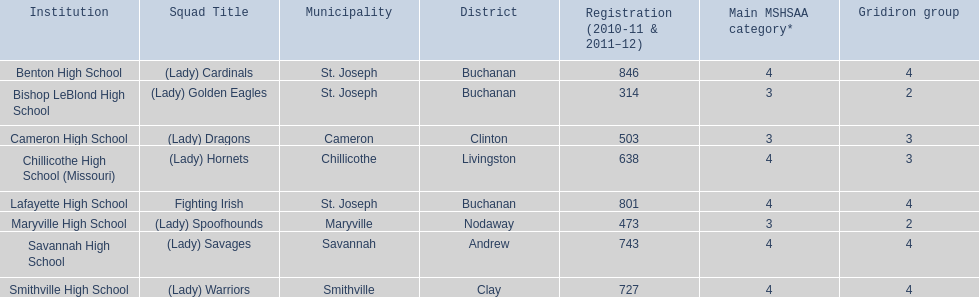What school in midland empire conference has 846 students enrolled? Benton High School. What school has 314 students enrolled? Bishop LeBlond High School. What school had 638 students enrolled? Chillicothe High School (Missouri). 